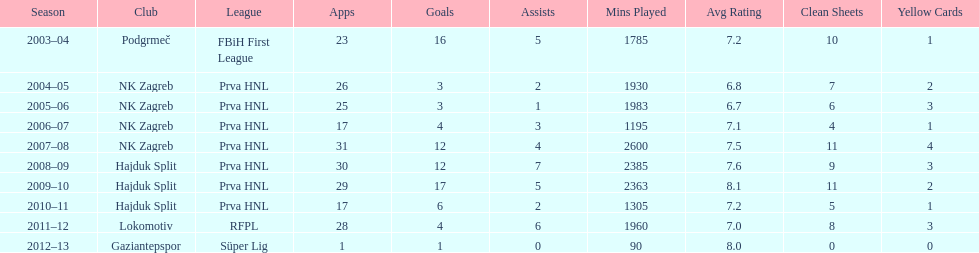The team with the most goals Hajduk Split. 